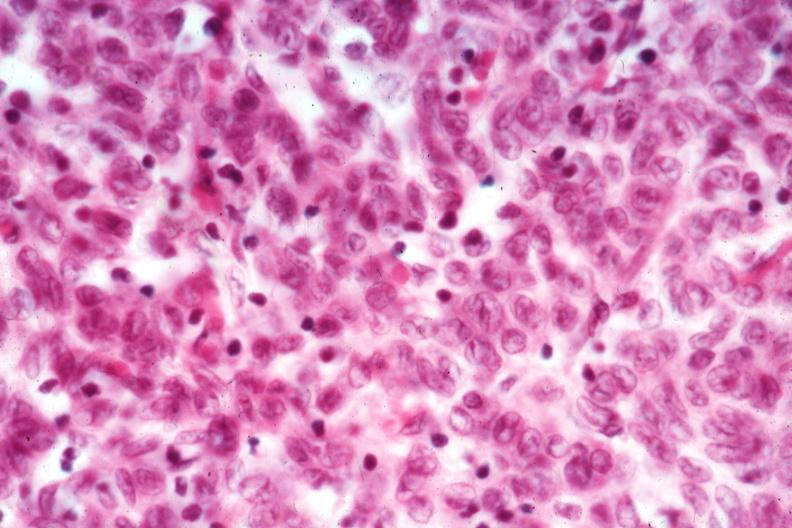what does this image show?
Answer the question using a single word or phrase. Cell detail good epithelial dominance 